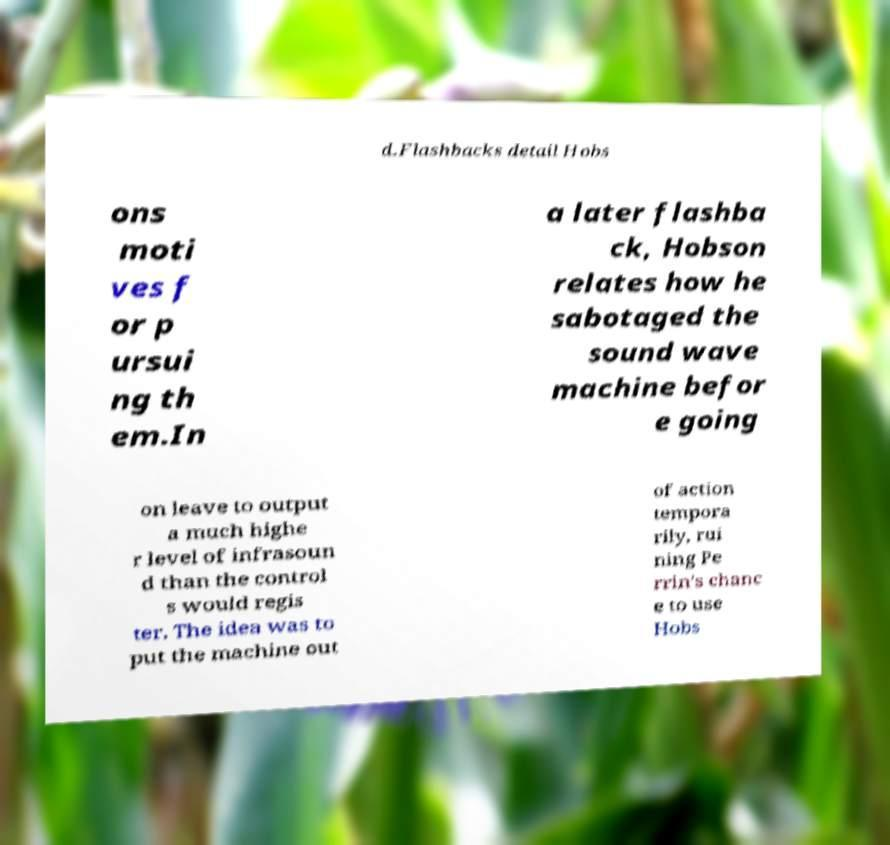Please identify and transcribe the text found in this image. d.Flashbacks detail Hobs ons moti ves f or p ursui ng th em.In a later flashba ck, Hobson relates how he sabotaged the sound wave machine befor e going on leave to output a much highe r level of infrasoun d than the control s would regis ter. The idea was to put the machine out of action tempora rily, rui ning Pe rrin's chanc e to use Hobs 